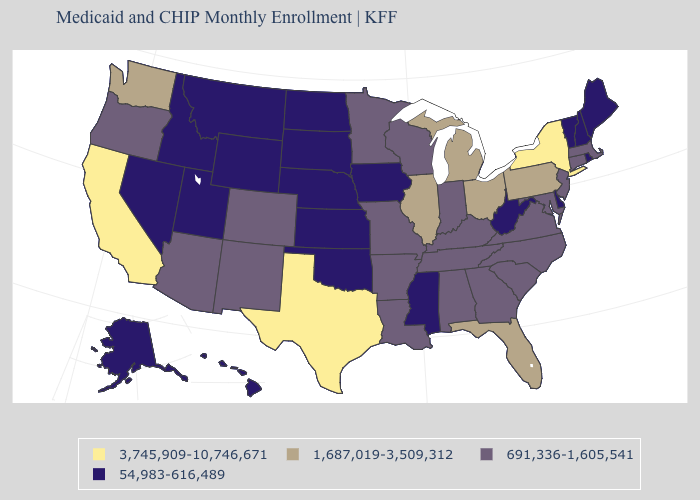Name the states that have a value in the range 54,983-616,489?
Concise answer only. Alaska, Delaware, Hawaii, Idaho, Iowa, Kansas, Maine, Mississippi, Montana, Nebraska, Nevada, New Hampshire, North Dakota, Oklahoma, Rhode Island, South Dakota, Utah, Vermont, West Virginia, Wyoming. What is the value of Montana?
Short answer required. 54,983-616,489. What is the value of Missouri?
Answer briefly. 691,336-1,605,541. Name the states that have a value in the range 54,983-616,489?
Write a very short answer. Alaska, Delaware, Hawaii, Idaho, Iowa, Kansas, Maine, Mississippi, Montana, Nebraska, Nevada, New Hampshire, North Dakota, Oklahoma, Rhode Island, South Dakota, Utah, Vermont, West Virginia, Wyoming. Which states have the lowest value in the USA?
Be succinct. Alaska, Delaware, Hawaii, Idaho, Iowa, Kansas, Maine, Mississippi, Montana, Nebraska, Nevada, New Hampshire, North Dakota, Oklahoma, Rhode Island, South Dakota, Utah, Vermont, West Virginia, Wyoming. Name the states that have a value in the range 1,687,019-3,509,312?
Answer briefly. Florida, Illinois, Michigan, Ohio, Pennsylvania, Washington. Name the states that have a value in the range 1,687,019-3,509,312?
Write a very short answer. Florida, Illinois, Michigan, Ohio, Pennsylvania, Washington. Does Oklahoma have the lowest value in the South?
Answer briefly. Yes. Name the states that have a value in the range 691,336-1,605,541?
Keep it brief. Alabama, Arizona, Arkansas, Colorado, Connecticut, Georgia, Indiana, Kentucky, Louisiana, Maryland, Massachusetts, Minnesota, Missouri, New Jersey, New Mexico, North Carolina, Oregon, South Carolina, Tennessee, Virginia, Wisconsin. Name the states that have a value in the range 3,745,909-10,746,671?
Write a very short answer. California, New York, Texas. What is the value of New Jersey?
Be succinct. 691,336-1,605,541. Which states hav the highest value in the Northeast?
Quick response, please. New York. What is the highest value in the Northeast ?
Concise answer only. 3,745,909-10,746,671. Name the states that have a value in the range 3,745,909-10,746,671?
Quick response, please. California, New York, Texas. Name the states that have a value in the range 1,687,019-3,509,312?
Short answer required. Florida, Illinois, Michigan, Ohio, Pennsylvania, Washington. 